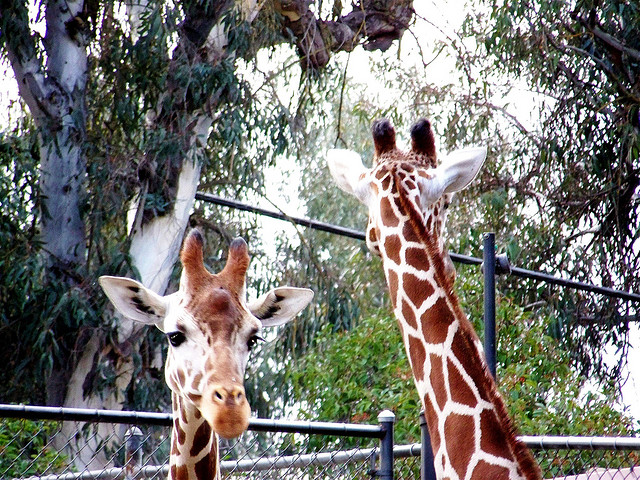<image>What kind of tree is in the background? I am not sure what kind of tree is in the background as it could be a mango, elm, poplar, african, acacia, eucalyptus or maple tree. What kind of tree is in the background? I am not sure what kind of tree is in the background. It can be seen as mango, elm, poplar, african, acacia, eucalyptus, or maple. 